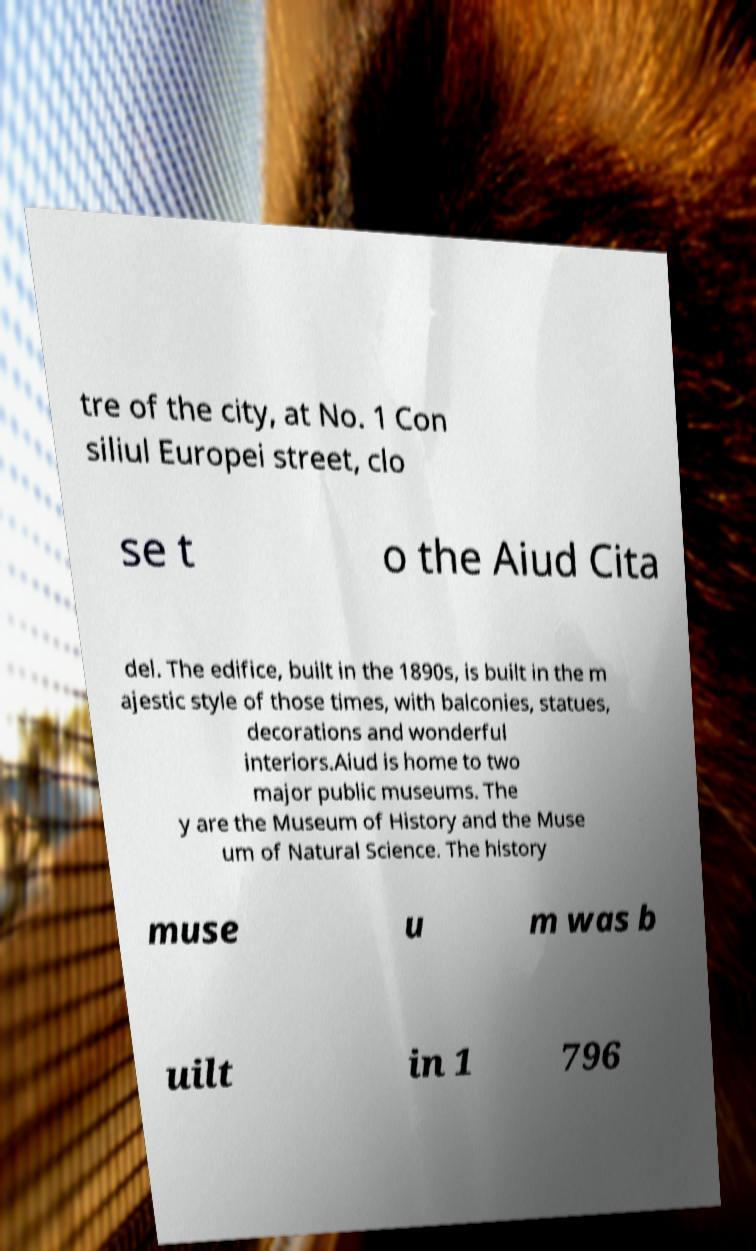What messages or text are displayed in this image? I need them in a readable, typed format. tre of the city, at No. 1 Con siliul Europei street, clo se t o the Aiud Cita del. The edifice, built in the 1890s, is built in the m ajestic style of those times, with balconies, statues, decorations and wonderful interiors.Aiud is home to two major public museums. The y are the Museum of History and the Muse um of Natural Science. The history muse u m was b uilt in 1 796 